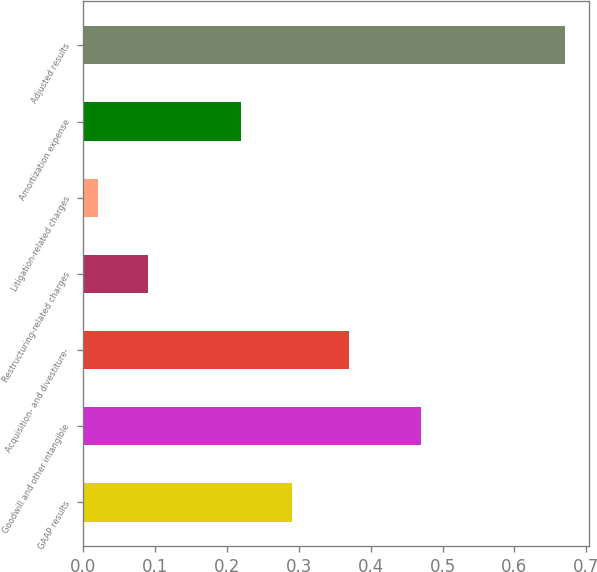Convert chart to OTSL. <chart><loc_0><loc_0><loc_500><loc_500><bar_chart><fcel>GAAP results<fcel>Goodwill and other intangible<fcel>Acquisition- and divestiture-<fcel>Restructuring-related charges<fcel>Litigation-related charges<fcel>Amortization expense<fcel>Adjusted results<nl><fcel>0.29<fcel>0.47<fcel>0.37<fcel>0.09<fcel>0.02<fcel>0.22<fcel>0.67<nl></chart> 